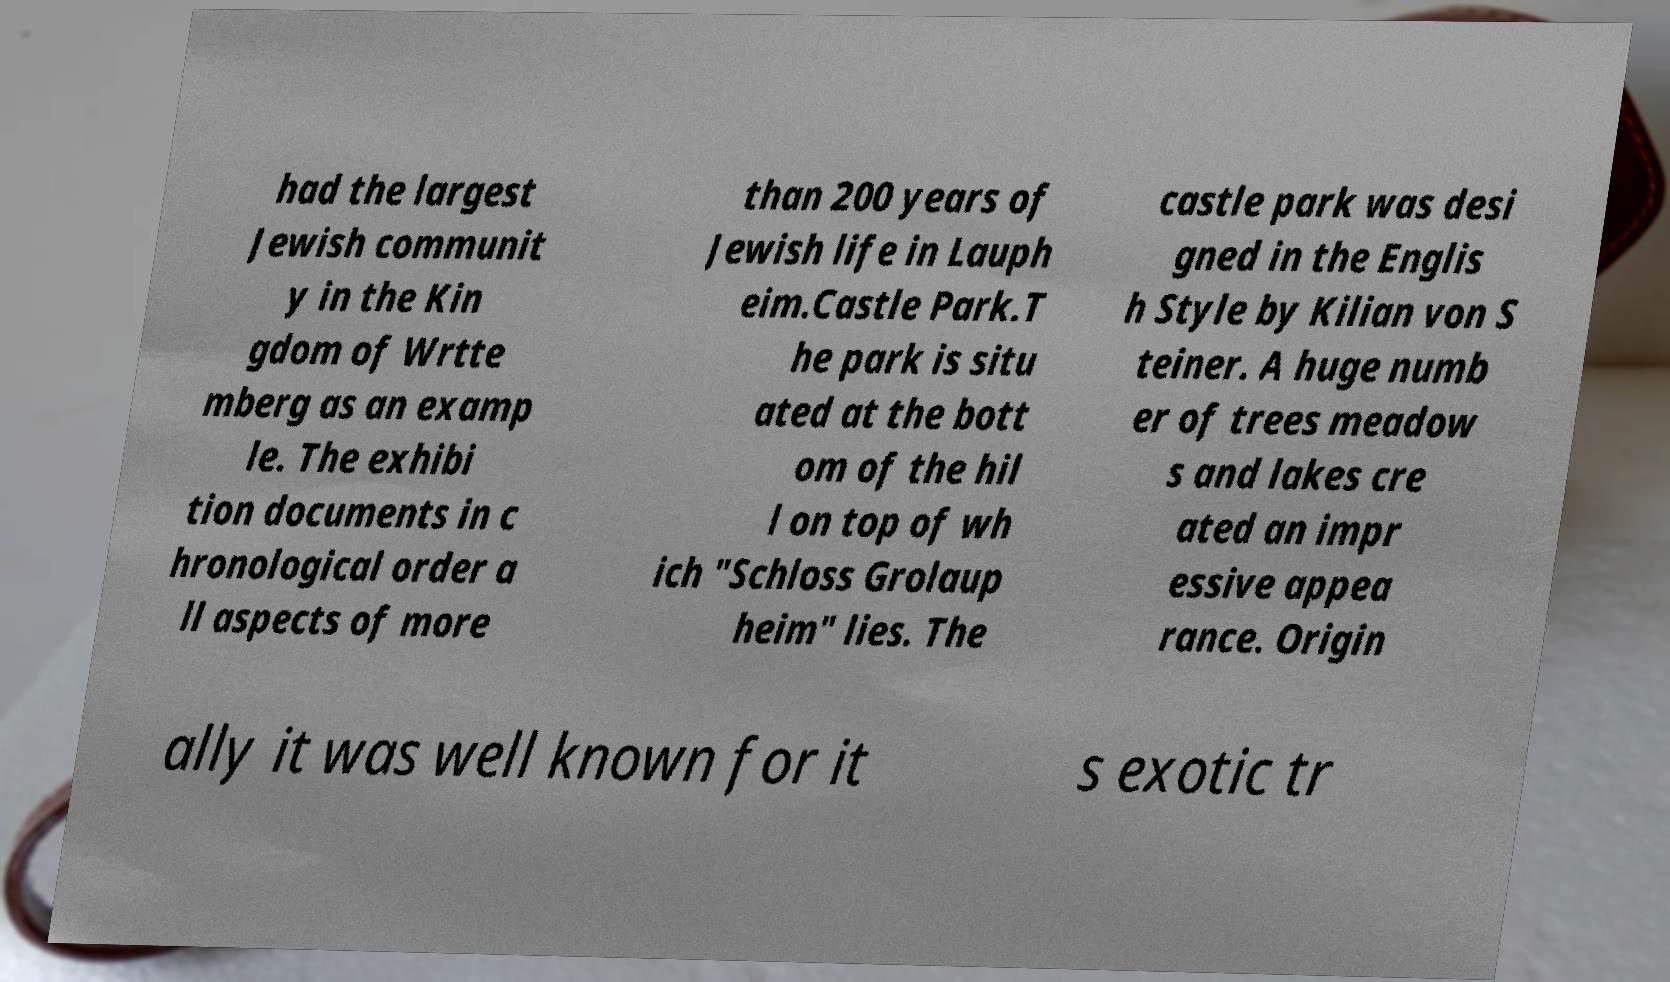Can you accurately transcribe the text from the provided image for me? had the largest Jewish communit y in the Kin gdom of Wrtte mberg as an examp le. The exhibi tion documents in c hronological order a ll aspects of more than 200 years of Jewish life in Lauph eim.Castle Park.T he park is situ ated at the bott om of the hil l on top of wh ich "Schloss Grolaup heim" lies. The castle park was desi gned in the Englis h Style by Kilian von S teiner. A huge numb er of trees meadow s and lakes cre ated an impr essive appea rance. Origin ally it was well known for it s exotic tr 